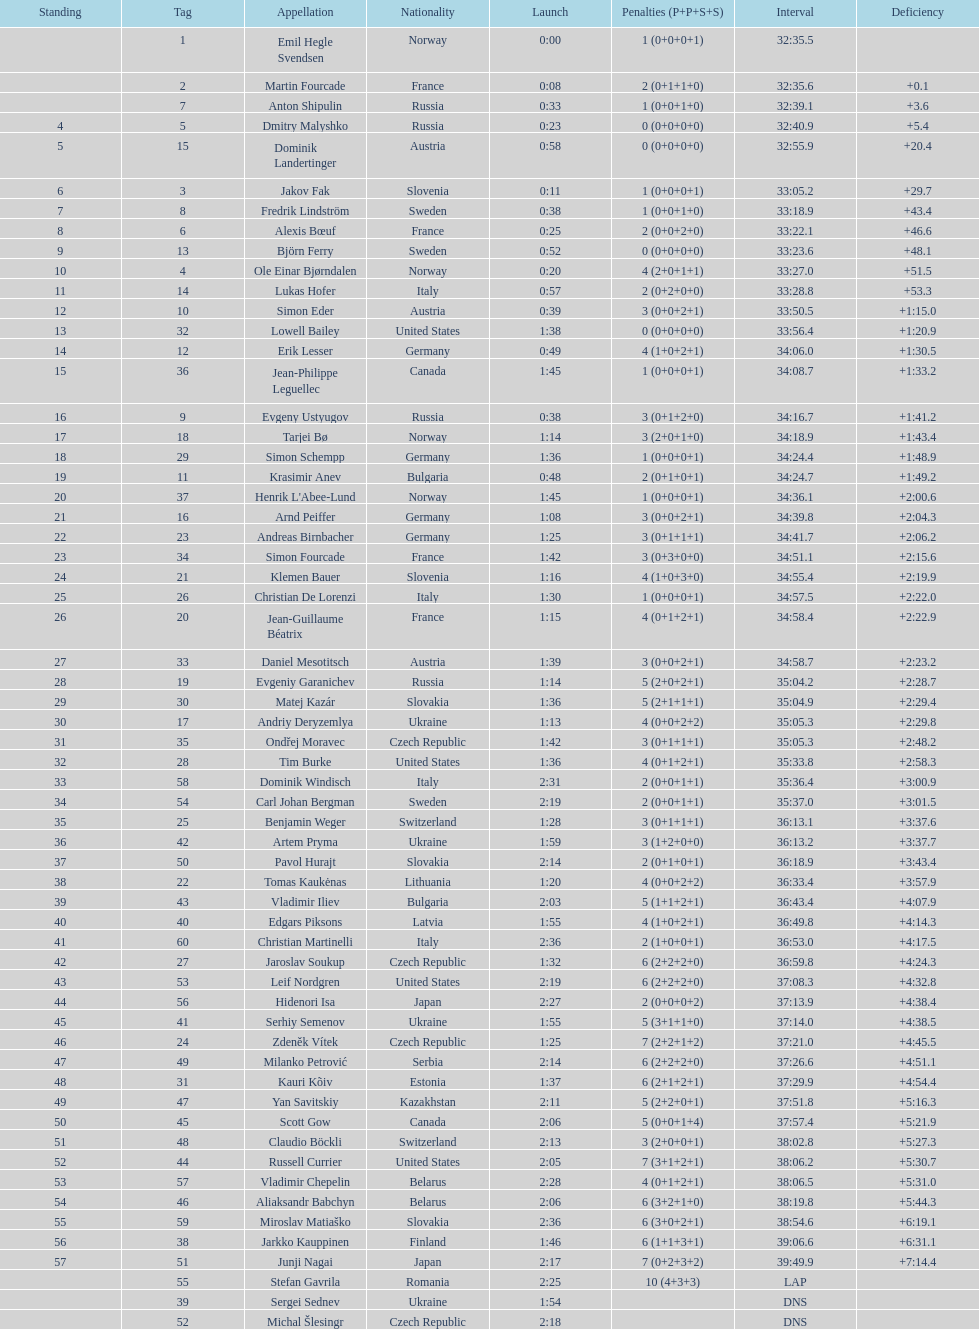How many penalties did germany get all together? 11. 